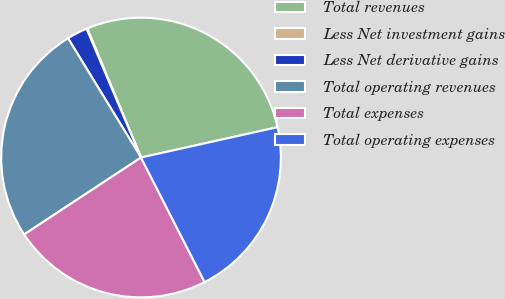Convert chart to OTSL. <chart><loc_0><loc_0><loc_500><loc_500><pie_chart><fcel>Total revenues<fcel>Less Net investment gains<fcel>Less Net derivative gains<fcel>Total operating revenues<fcel>Total expenses<fcel>Total operating expenses<nl><fcel>27.8%<fcel>0.09%<fcel>2.37%<fcel>25.53%<fcel>23.25%<fcel>20.97%<nl></chart> 